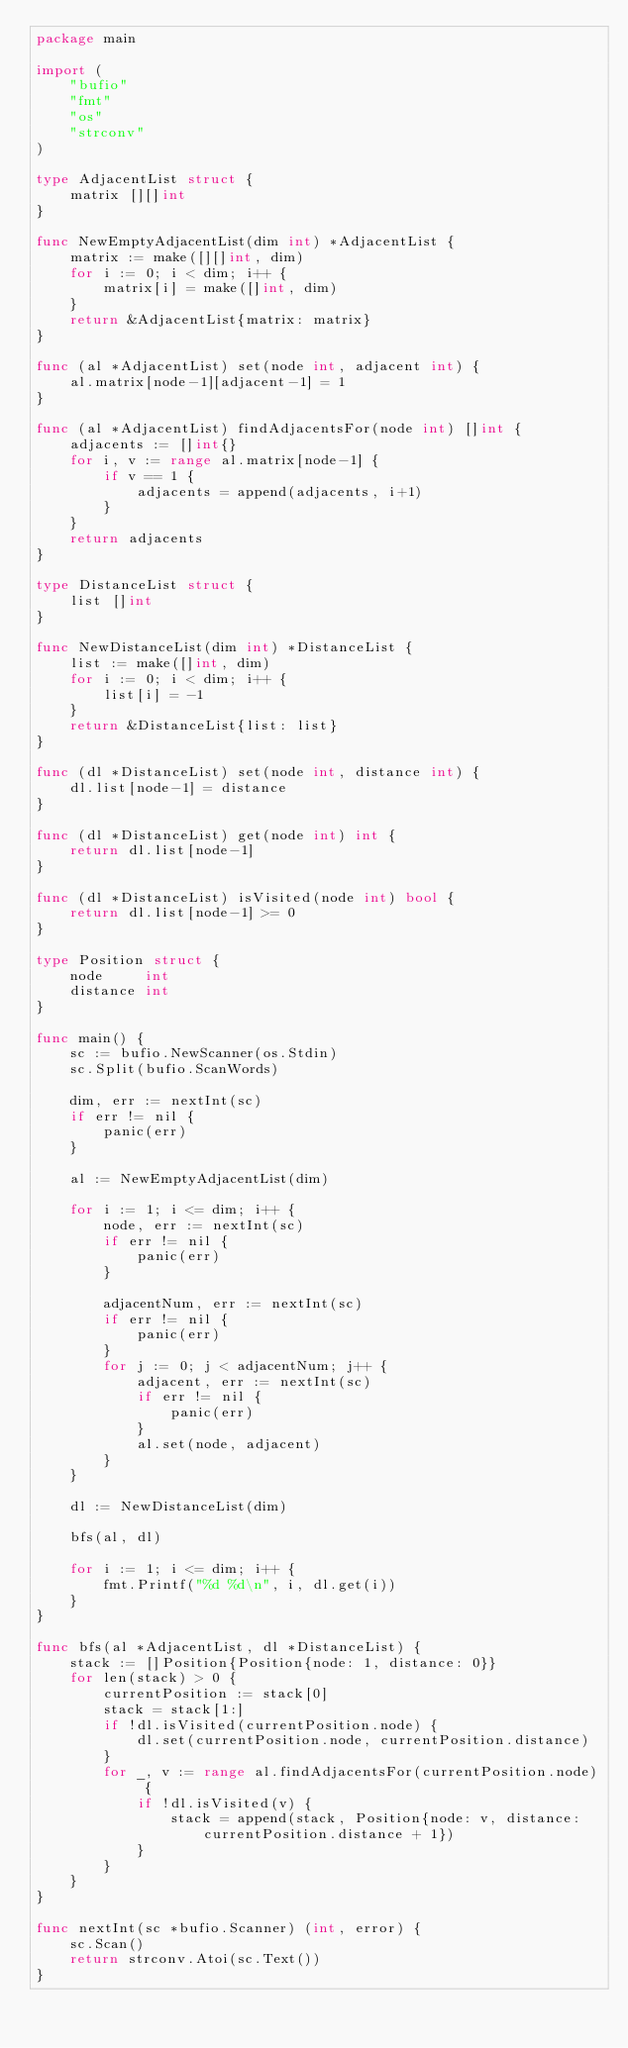Convert code to text. <code><loc_0><loc_0><loc_500><loc_500><_Go_>package main

import (
	"bufio"
	"fmt"
	"os"
	"strconv"
)

type AdjacentList struct {
	matrix [][]int
}

func NewEmptyAdjacentList(dim int) *AdjacentList {
	matrix := make([][]int, dim)
	for i := 0; i < dim; i++ {
		matrix[i] = make([]int, dim)
	}
	return &AdjacentList{matrix: matrix}
}

func (al *AdjacentList) set(node int, adjacent int) {
	al.matrix[node-1][adjacent-1] = 1
}

func (al *AdjacentList) findAdjacentsFor(node int) []int {
	adjacents := []int{}
	for i, v := range al.matrix[node-1] {
		if v == 1 {
			adjacents = append(adjacents, i+1)
		}
	}
	return adjacents
}

type DistanceList struct {
	list []int
}

func NewDistanceList(dim int) *DistanceList {
	list := make([]int, dim)
	for i := 0; i < dim; i++ {
		list[i] = -1
	}
	return &DistanceList{list: list}
}

func (dl *DistanceList) set(node int, distance int) {
	dl.list[node-1] = distance
}

func (dl *DistanceList) get(node int) int {
	return dl.list[node-1]
}

func (dl *DistanceList) isVisited(node int) bool {
	return dl.list[node-1] >= 0
}

type Position struct {
	node     int
	distance int
}

func main() {
	sc := bufio.NewScanner(os.Stdin)
	sc.Split(bufio.ScanWords)

	dim, err := nextInt(sc)
	if err != nil {
		panic(err)
	}

	al := NewEmptyAdjacentList(dim)

	for i := 1; i <= dim; i++ {
		node, err := nextInt(sc)
		if err != nil {
			panic(err)
		}

		adjacentNum, err := nextInt(sc)
		if err != nil {
			panic(err)
		}
		for j := 0; j < adjacentNum; j++ {
			adjacent, err := nextInt(sc)
			if err != nil {
				panic(err)
			}
			al.set(node, adjacent)
		}
	}

	dl := NewDistanceList(dim)

	bfs(al, dl)

	for i := 1; i <= dim; i++ {
		fmt.Printf("%d %d\n", i, dl.get(i))
	}
}

func bfs(al *AdjacentList, dl *DistanceList) {
	stack := []Position{Position{node: 1, distance: 0}}
	for len(stack) > 0 {
		currentPosition := stack[0]
		stack = stack[1:]
		if !dl.isVisited(currentPosition.node) {
			dl.set(currentPosition.node, currentPosition.distance)
		}
		for _, v := range al.findAdjacentsFor(currentPosition.node) {
			if !dl.isVisited(v) {
				stack = append(stack, Position{node: v, distance: currentPosition.distance + 1})
			}
		}
	}
}

func nextInt(sc *bufio.Scanner) (int, error) {
	sc.Scan()
	return strconv.Atoi(sc.Text())
}

</code> 